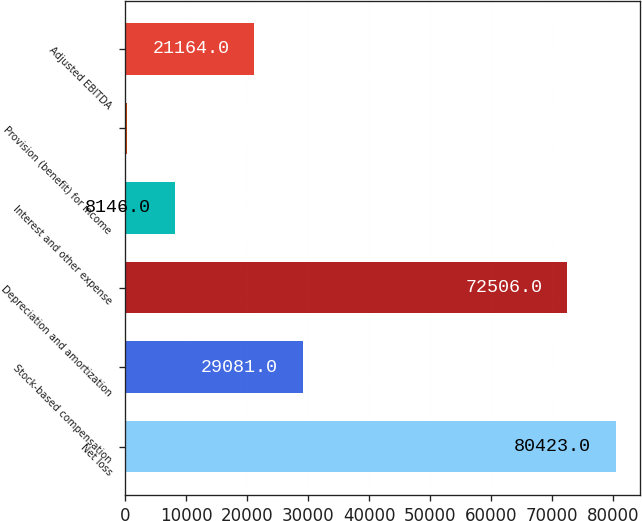<chart> <loc_0><loc_0><loc_500><loc_500><bar_chart><fcel>Net loss<fcel>Stock-based compensation<fcel>Depreciation and amortization<fcel>Interest and other expense<fcel>Provision (benefit) for income<fcel>Adjusted EBITDA<nl><fcel>80423<fcel>29081<fcel>72506<fcel>8146<fcel>229<fcel>21164<nl></chart> 